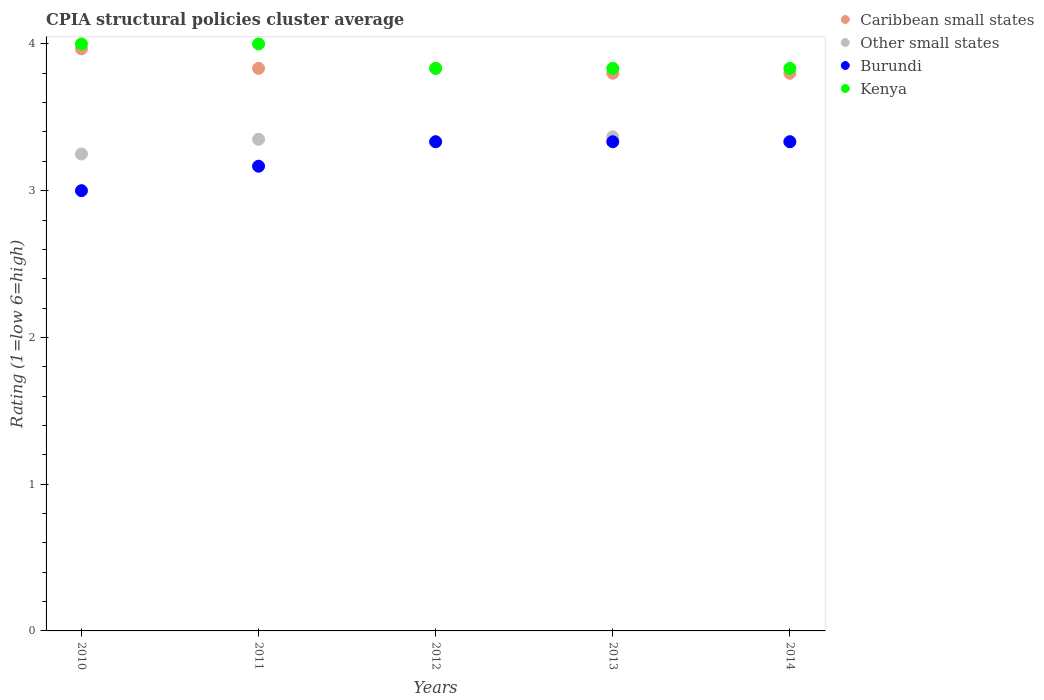Is the number of dotlines equal to the number of legend labels?
Offer a very short reply. Yes. Across all years, what is the minimum CPIA rating in Caribbean small states?
Ensure brevity in your answer.  3.8. In which year was the CPIA rating in Caribbean small states minimum?
Give a very brief answer. 2014. What is the total CPIA rating in Other small states in the graph?
Keep it short and to the point. 16.63. What is the difference between the CPIA rating in Burundi in 2011 and that in 2014?
Provide a succinct answer. -0.17. What is the difference between the CPIA rating in Burundi in 2011 and the CPIA rating in Other small states in 2012?
Keep it short and to the point. -0.17. What is the average CPIA rating in Caribbean small states per year?
Give a very brief answer. 3.85. In the year 2012, what is the difference between the CPIA rating in Other small states and CPIA rating in Kenya?
Provide a succinct answer. -0.5. What is the ratio of the CPIA rating in Burundi in 2010 to that in 2012?
Offer a very short reply. 0.9. What is the difference between the highest and the lowest CPIA rating in Caribbean small states?
Give a very brief answer. 0.17. How many dotlines are there?
Your response must be concise. 4. How many years are there in the graph?
Provide a succinct answer. 5. Are the values on the major ticks of Y-axis written in scientific E-notation?
Keep it short and to the point. No. Does the graph contain any zero values?
Offer a very short reply. No. Where does the legend appear in the graph?
Ensure brevity in your answer.  Top right. How many legend labels are there?
Make the answer very short. 4. What is the title of the graph?
Offer a very short reply. CPIA structural policies cluster average. Does "South Africa" appear as one of the legend labels in the graph?
Provide a short and direct response. No. What is the label or title of the Y-axis?
Provide a succinct answer. Rating (1=low 6=high). What is the Rating (1=low 6=high) of Caribbean small states in 2010?
Give a very brief answer. 3.97. What is the Rating (1=low 6=high) of Kenya in 2010?
Give a very brief answer. 4. What is the Rating (1=low 6=high) of Caribbean small states in 2011?
Your response must be concise. 3.83. What is the Rating (1=low 6=high) in Other small states in 2011?
Your answer should be compact. 3.35. What is the Rating (1=low 6=high) in Burundi in 2011?
Ensure brevity in your answer.  3.17. What is the Rating (1=low 6=high) of Caribbean small states in 2012?
Provide a succinct answer. 3.83. What is the Rating (1=low 6=high) in Other small states in 2012?
Your response must be concise. 3.33. What is the Rating (1=low 6=high) in Burundi in 2012?
Ensure brevity in your answer.  3.33. What is the Rating (1=low 6=high) in Kenya in 2012?
Your answer should be very brief. 3.83. What is the Rating (1=low 6=high) of Caribbean small states in 2013?
Make the answer very short. 3.8. What is the Rating (1=low 6=high) in Other small states in 2013?
Your response must be concise. 3.37. What is the Rating (1=low 6=high) of Burundi in 2013?
Give a very brief answer. 3.33. What is the Rating (1=low 6=high) in Kenya in 2013?
Provide a succinct answer. 3.83. What is the Rating (1=low 6=high) in Caribbean small states in 2014?
Your answer should be compact. 3.8. What is the Rating (1=low 6=high) in Other small states in 2014?
Your answer should be very brief. 3.33. What is the Rating (1=low 6=high) of Burundi in 2014?
Your response must be concise. 3.33. What is the Rating (1=low 6=high) of Kenya in 2014?
Make the answer very short. 3.83. Across all years, what is the maximum Rating (1=low 6=high) in Caribbean small states?
Offer a terse response. 3.97. Across all years, what is the maximum Rating (1=low 6=high) of Other small states?
Provide a short and direct response. 3.37. Across all years, what is the maximum Rating (1=low 6=high) of Burundi?
Provide a short and direct response. 3.33. Across all years, what is the minimum Rating (1=low 6=high) of Caribbean small states?
Your response must be concise. 3.8. Across all years, what is the minimum Rating (1=low 6=high) in Other small states?
Provide a succinct answer. 3.25. Across all years, what is the minimum Rating (1=low 6=high) of Burundi?
Your answer should be compact. 3. Across all years, what is the minimum Rating (1=low 6=high) in Kenya?
Provide a succinct answer. 3.83. What is the total Rating (1=low 6=high) of Caribbean small states in the graph?
Make the answer very short. 19.23. What is the total Rating (1=low 6=high) of Other small states in the graph?
Your response must be concise. 16.63. What is the total Rating (1=low 6=high) in Burundi in the graph?
Offer a very short reply. 16.17. What is the total Rating (1=low 6=high) of Kenya in the graph?
Your response must be concise. 19.5. What is the difference between the Rating (1=low 6=high) of Caribbean small states in 2010 and that in 2011?
Ensure brevity in your answer.  0.13. What is the difference between the Rating (1=low 6=high) of Kenya in 2010 and that in 2011?
Provide a succinct answer. 0. What is the difference between the Rating (1=low 6=high) in Caribbean small states in 2010 and that in 2012?
Offer a terse response. 0.13. What is the difference between the Rating (1=low 6=high) of Other small states in 2010 and that in 2012?
Your response must be concise. -0.08. What is the difference between the Rating (1=low 6=high) of Kenya in 2010 and that in 2012?
Offer a very short reply. 0.17. What is the difference between the Rating (1=low 6=high) in Caribbean small states in 2010 and that in 2013?
Your response must be concise. 0.17. What is the difference between the Rating (1=low 6=high) of Other small states in 2010 and that in 2013?
Your response must be concise. -0.12. What is the difference between the Rating (1=low 6=high) in Burundi in 2010 and that in 2013?
Offer a terse response. -0.33. What is the difference between the Rating (1=low 6=high) in Kenya in 2010 and that in 2013?
Provide a short and direct response. 0.17. What is the difference between the Rating (1=low 6=high) of Other small states in 2010 and that in 2014?
Your response must be concise. -0.08. What is the difference between the Rating (1=low 6=high) of Burundi in 2010 and that in 2014?
Provide a short and direct response. -0.33. What is the difference between the Rating (1=low 6=high) in Caribbean small states in 2011 and that in 2012?
Keep it short and to the point. 0. What is the difference between the Rating (1=low 6=high) in Other small states in 2011 and that in 2012?
Provide a succinct answer. 0.02. What is the difference between the Rating (1=low 6=high) in Kenya in 2011 and that in 2012?
Keep it short and to the point. 0.17. What is the difference between the Rating (1=low 6=high) of Caribbean small states in 2011 and that in 2013?
Provide a short and direct response. 0.03. What is the difference between the Rating (1=low 6=high) in Other small states in 2011 and that in 2013?
Provide a succinct answer. -0.02. What is the difference between the Rating (1=low 6=high) of Caribbean small states in 2011 and that in 2014?
Offer a terse response. 0.03. What is the difference between the Rating (1=low 6=high) in Other small states in 2011 and that in 2014?
Give a very brief answer. 0.02. What is the difference between the Rating (1=low 6=high) in Kenya in 2011 and that in 2014?
Keep it short and to the point. 0.17. What is the difference between the Rating (1=low 6=high) in Other small states in 2012 and that in 2013?
Offer a very short reply. -0.03. What is the difference between the Rating (1=low 6=high) in Kenya in 2012 and that in 2013?
Provide a succinct answer. 0. What is the difference between the Rating (1=low 6=high) of Other small states in 2012 and that in 2014?
Your answer should be compact. 0. What is the difference between the Rating (1=low 6=high) in Burundi in 2012 and that in 2014?
Your answer should be compact. 0. What is the difference between the Rating (1=low 6=high) of Kenya in 2012 and that in 2014?
Give a very brief answer. 0. What is the difference between the Rating (1=low 6=high) of Other small states in 2013 and that in 2014?
Offer a terse response. 0.03. What is the difference between the Rating (1=low 6=high) of Burundi in 2013 and that in 2014?
Your answer should be very brief. 0. What is the difference between the Rating (1=low 6=high) in Caribbean small states in 2010 and the Rating (1=low 6=high) in Other small states in 2011?
Provide a short and direct response. 0.62. What is the difference between the Rating (1=low 6=high) of Caribbean small states in 2010 and the Rating (1=low 6=high) of Kenya in 2011?
Keep it short and to the point. -0.03. What is the difference between the Rating (1=low 6=high) of Other small states in 2010 and the Rating (1=low 6=high) of Burundi in 2011?
Your answer should be compact. 0.08. What is the difference between the Rating (1=low 6=high) of Other small states in 2010 and the Rating (1=low 6=high) of Kenya in 2011?
Provide a short and direct response. -0.75. What is the difference between the Rating (1=low 6=high) of Caribbean small states in 2010 and the Rating (1=low 6=high) of Other small states in 2012?
Give a very brief answer. 0.63. What is the difference between the Rating (1=low 6=high) of Caribbean small states in 2010 and the Rating (1=low 6=high) of Burundi in 2012?
Offer a terse response. 0.63. What is the difference between the Rating (1=low 6=high) in Caribbean small states in 2010 and the Rating (1=low 6=high) in Kenya in 2012?
Provide a short and direct response. 0.13. What is the difference between the Rating (1=low 6=high) in Other small states in 2010 and the Rating (1=low 6=high) in Burundi in 2012?
Your answer should be compact. -0.08. What is the difference between the Rating (1=low 6=high) in Other small states in 2010 and the Rating (1=low 6=high) in Kenya in 2012?
Offer a very short reply. -0.58. What is the difference between the Rating (1=low 6=high) of Caribbean small states in 2010 and the Rating (1=low 6=high) of Other small states in 2013?
Your answer should be very brief. 0.6. What is the difference between the Rating (1=low 6=high) of Caribbean small states in 2010 and the Rating (1=low 6=high) of Burundi in 2013?
Your answer should be very brief. 0.63. What is the difference between the Rating (1=low 6=high) of Caribbean small states in 2010 and the Rating (1=low 6=high) of Kenya in 2013?
Your response must be concise. 0.13. What is the difference between the Rating (1=low 6=high) of Other small states in 2010 and the Rating (1=low 6=high) of Burundi in 2013?
Make the answer very short. -0.08. What is the difference between the Rating (1=low 6=high) of Other small states in 2010 and the Rating (1=low 6=high) of Kenya in 2013?
Ensure brevity in your answer.  -0.58. What is the difference between the Rating (1=low 6=high) in Burundi in 2010 and the Rating (1=low 6=high) in Kenya in 2013?
Offer a very short reply. -0.83. What is the difference between the Rating (1=low 6=high) in Caribbean small states in 2010 and the Rating (1=low 6=high) in Other small states in 2014?
Provide a succinct answer. 0.63. What is the difference between the Rating (1=low 6=high) in Caribbean small states in 2010 and the Rating (1=low 6=high) in Burundi in 2014?
Give a very brief answer. 0.63. What is the difference between the Rating (1=low 6=high) of Caribbean small states in 2010 and the Rating (1=low 6=high) of Kenya in 2014?
Give a very brief answer. 0.13. What is the difference between the Rating (1=low 6=high) in Other small states in 2010 and the Rating (1=low 6=high) in Burundi in 2014?
Your response must be concise. -0.08. What is the difference between the Rating (1=low 6=high) in Other small states in 2010 and the Rating (1=low 6=high) in Kenya in 2014?
Ensure brevity in your answer.  -0.58. What is the difference between the Rating (1=low 6=high) in Burundi in 2010 and the Rating (1=low 6=high) in Kenya in 2014?
Offer a terse response. -0.83. What is the difference between the Rating (1=low 6=high) in Caribbean small states in 2011 and the Rating (1=low 6=high) in Other small states in 2012?
Your answer should be compact. 0.5. What is the difference between the Rating (1=low 6=high) of Caribbean small states in 2011 and the Rating (1=low 6=high) of Kenya in 2012?
Your answer should be very brief. 0. What is the difference between the Rating (1=low 6=high) in Other small states in 2011 and the Rating (1=low 6=high) in Burundi in 2012?
Offer a very short reply. 0.02. What is the difference between the Rating (1=low 6=high) of Other small states in 2011 and the Rating (1=low 6=high) of Kenya in 2012?
Ensure brevity in your answer.  -0.48. What is the difference between the Rating (1=low 6=high) of Caribbean small states in 2011 and the Rating (1=low 6=high) of Other small states in 2013?
Offer a terse response. 0.47. What is the difference between the Rating (1=low 6=high) of Other small states in 2011 and the Rating (1=low 6=high) of Burundi in 2013?
Provide a succinct answer. 0.02. What is the difference between the Rating (1=low 6=high) in Other small states in 2011 and the Rating (1=low 6=high) in Kenya in 2013?
Provide a succinct answer. -0.48. What is the difference between the Rating (1=low 6=high) of Other small states in 2011 and the Rating (1=low 6=high) of Burundi in 2014?
Offer a very short reply. 0.02. What is the difference between the Rating (1=low 6=high) in Other small states in 2011 and the Rating (1=low 6=high) in Kenya in 2014?
Give a very brief answer. -0.48. What is the difference between the Rating (1=low 6=high) of Caribbean small states in 2012 and the Rating (1=low 6=high) of Other small states in 2013?
Offer a very short reply. 0.47. What is the difference between the Rating (1=low 6=high) in Other small states in 2012 and the Rating (1=low 6=high) in Kenya in 2013?
Ensure brevity in your answer.  -0.5. What is the difference between the Rating (1=low 6=high) of Caribbean small states in 2012 and the Rating (1=low 6=high) of Other small states in 2014?
Give a very brief answer. 0.5. What is the difference between the Rating (1=low 6=high) in Caribbean small states in 2012 and the Rating (1=low 6=high) in Burundi in 2014?
Provide a short and direct response. 0.5. What is the difference between the Rating (1=low 6=high) in Caribbean small states in 2012 and the Rating (1=low 6=high) in Kenya in 2014?
Provide a succinct answer. 0. What is the difference between the Rating (1=low 6=high) of Other small states in 2012 and the Rating (1=low 6=high) of Burundi in 2014?
Keep it short and to the point. 0. What is the difference between the Rating (1=low 6=high) of Other small states in 2012 and the Rating (1=low 6=high) of Kenya in 2014?
Make the answer very short. -0.5. What is the difference between the Rating (1=low 6=high) in Burundi in 2012 and the Rating (1=low 6=high) in Kenya in 2014?
Your answer should be very brief. -0.5. What is the difference between the Rating (1=low 6=high) in Caribbean small states in 2013 and the Rating (1=low 6=high) in Other small states in 2014?
Offer a terse response. 0.47. What is the difference between the Rating (1=low 6=high) in Caribbean small states in 2013 and the Rating (1=low 6=high) in Burundi in 2014?
Provide a succinct answer. 0.47. What is the difference between the Rating (1=low 6=high) in Caribbean small states in 2013 and the Rating (1=low 6=high) in Kenya in 2014?
Ensure brevity in your answer.  -0.03. What is the difference between the Rating (1=low 6=high) in Other small states in 2013 and the Rating (1=low 6=high) in Burundi in 2014?
Your answer should be compact. 0.03. What is the difference between the Rating (1=low 6=high) of Other small states in 2013 and the Rating (1=low 6=high) of Kenya in 2014?
Offer a very short reply. -0.47. What is the average Rating (1=low 6=high) of Caribbean small states per year?
Your answer should be very brief. 3.85. What is the average Rating (1=low 6=high) in Other small states per year?
Your answer should be compact. 3.33. What is the average Rating (1=low 6=high) in Burundi per year?
Offer a very short reply. 3.23. What is the average Rating (1=low 6=high) in Kenya per year?
Provide a short and direct response. 3.9. In the year 2010, what is the difference between the Rating (1=low 6=high) in Caribbean small states and Rating (1=low 6=high) in Other small states?
Provide a succinct answer. 0.72. In the year 2010, what is the difference between the Rating (1=low 6=high) of Caribbean small states and Rating (1=low 6=high) of Burundi?
Your answer should be very brief. 0.97. In the year 2010, what is the difference between the Rating (1=low 6=high) in Caribbean small states and Rating (1=low 6=high) in Kenya?
Keep it short and to the point. -0.03. In the year 2010, what is the difference between the Rating (1=low 6=high) of Other small states and Rating (1=low 6=high) of Burundi?
Keep it short and to the point. 0.25. In the year 2010, what is the difference between the Rating (1=low 6=high) in Other small states and Rating (1=low 6=high) in Kenya?
Your answer should be compact. -0.75. In the year 2011, what is the difference between the Rating (1=low 6=high) of Caribbean small states and Rating (1=low 6=high) of Other small states?
Your answer should be very brief. 0.48. In the year 2011, what is the difference between the Rating (1=low 6=high) of Caribbean small states and Rating (1=low 6=high) of Burundi?
Provide a succinct answer. 0.67. In the year 2011, what is the difference between the Rating (1=low 6=high) in Other small states and Rating (1=low 6=high) in Burundi?
Make the answer very short. 0.18. In the year 2011, what is the difference between the Rating (1=low 6=high) in Other small states and Rating (1=low 6=high) in Kenya?
Make the answer very short. -0.65. In the year 2012, what is the difference between the Rating (1=low 6=high) in Caribbean small states and Rating (1=low 6=high) in Burundi?
Your answer should be very brief. 0.5. In the year 2012, what is the difference between the Rating (1=low 6=high) in Other small states and Rating (1=low 6=high) in Kenya?
Give a very brief answer. -0.5. In the year 2013, what is the difference between the Rating (1=low 6=high) of Caribbean small states and Rating (1=low 6=high) of Other small states?
Keep it short and to the point. 0.43. In the year 2013, what is the difference between the Rating (1=low 6=high) of Caribbean small states and Rating (1=low 6=high) of Burundi?
Make the answer very short. 0.47. In the year 2013, what is the difference between the Rating (1=low 6=high) in Caribbean small states and Rating (1=low 6=high) in Kenya?
Provide a short and direct response. -0.03. In the year 2013, what is the difference between the Rating (1=low 6=high) in Other small states and Rating (1=low 6=high) in Burundi?
Provide a short and direct response. 0.03. In the year 2013, what is the difference between the Rating (1=low 6=high) of Other small states and Rating (1=low 6=high) of Kenya?
Provide a short and direct response. -0.47. In the year 2013, what is the difference between the Rating (1=low 6=high) of Burundi and Rating (1=low 6=high) of Kenya?
Your answer should be compact. -0.5. In the year 2014, what is the difference between the Rating (1=low 6=high) in Caribbean small states and Rating (1=low 6=high) in Other small states?
Keep it short and to the point. 0.47. In the year 2014, what is the difference between the Rating (1=low 6=high) in Caribbean small states and Rating (1=low 6=high) in Burundi?
Keep it short and to the point. 0.47. In the year 2014, what is the difference between the Rating (1=low 6=high) in Caribbean small states and Rating (1=low 6=high) in Kenya?
Keep it short and to the point. -0.03. In the year 2014, what is the difference between the Rating (1=low 6=high) of Other small states and Rating (1=low 6=high) of Burundi?
Offer a terse response. 0. What is the ratio of the Rating (1=low 6=high) in Caribbean small states in 2010 to that in 2011?
Provide a succinct answer. 1.03. What is the ratio of the Rating (1=low 6=high) in Other small states in 2010 to that in 2011?
Give a very brief answer. 0.97. What is the ratio of the Rating (1=low 6=high) of Burundi in 2010 to that in 2011?
Provide a short and direct response. 0.95. What is the ratio of the Rating (1=low 6=high) in Kenya in 2010 to that in 2011?
Your response must be concise. 1. What is the ratio of the Rating (1=low 6=high) in Caribbean small states in 2010 to that in 2012?
Ensure brevity in your answer.  1.03. What is the ratio of the Rating (1=low 6=high) of Burundi in 2010 to that in 2012?
Offer a very short reply. 0.9. What is the ratio of the Rating (1=low 6=high) in Kenya in 2010 to that in 2012?
Your response must be concise. 1.04. What is the ratio of the Rating (1=low 6=high) in Caribbean small states in 2010 to that in 2013?
Provide a short and direct response. 1.04. What is the ratio of the Rating (1=low 6=high) in Other small states in 2010 to that in 2013?
Give a very brief answer. 0.97. What is the ratio of the Rating (1=low 6=high) of Burundi in 2010 to that in 2013?
Offer a terse response. 0.9. What is the ratio of the Rating (1=low 6=high) of Kenya in 2010 to that in 2013?
Make the answer very short. 1.04. What is the ratio of the Rating (1=low 6=high) in Caribbean small states in 2010 to that in 2014?
Ensure brevity in your answer.  1.04. What is the ratio of the Rating (1=low 6=high) of Kenya in 2010 to that in 2014?
Keep it short and to the point. 1.04. What is the ratio of the Rating (1=low 6=high) of Caribbean small states in 2011 to that in 2012?
Offer a very short reply. 1. What is the ratio of the Rating (1=low 6=high) of Burundi in 2011 to that in 2012?
Offer a terse response. 0.95. What is the ratio of the Rating (1=low 6=high) of Kenya in 2011 to that in 2012?
Ensure brevity in your answer.  1.04. What is the ratio of the Rating (1=low 6=high) in Caribbean small states in 2011 to that in 2013?
Keep it short and to the point. 1.01. What is the ratio of the Rating (1=low 6=high) in Kenya in 2011 to that in 2013?
Your answer should be compact. 1.04. What is the ratio of the Rating (1=low 6=high) of Caribbean small states in 2011 to that in 2014?
Keep it short and to the point. 1.01. What is the ratio of the Rating (1=low 6=high) in Other small states in 2011 to that in 2014?
Your answer should be compact. 1. What is the ratio of the Rating (1=low 6=high) of Kenya in 2011 to that in 2014?
Your answer should be compact. 1.04. What is the ratio of the Rating (1=low 6=high) in Caribbean small states in 2012 to that in 2013?
Keep it short and to the point. 1.01. What is the ratio of the Rating (1=low 6=high) of Other small states in 2012 to that in 2013?
Offer a very short reply. 0.99. What is the ratio of the Rating (1=low 6=high) of Burundi in 2012 to that in 2013?
Offer a very short reply. 1. What is the ratio of the Rating (1=low 6=high) in Kenya in 2012 to that in 2013?
Offer a very short reply. 1. What is the ratio of the Rating (1=low 6=high) of Caribbean small states in 2012 to that in 2014?
Offer a terse response. 1.01. What is the ratio of the Rating (1=low 6=high) of Other small states in 2013 to that in 2014?
Offer a very short reply. 1.01. What is the difference between the highest and the second highest Rating (1=low 6=high) in Caribbean small states?
Your answer should be compact. 0.13. What is the difference between the highest and the second highest Rating (1=low 6=high) in Other small states?
Your answer should be very brief. 0.02. What is the difference between the highest and the second highest Rating (1=low 6=high) of Burundi?
Your answer should be very brief. 0. What is the difference between the highest and the lowest Rating (1=low 6=high) of Caribbean small states?
Provide a succinct answer. 0.17. What is the difference between the highest and the lowest Rating (1=low 6=high) of Other small states?
Make the answer very short. 0.12. What is the difference between the highest and the lowest Rating (1=low 6=high) of Burundi?
Provide a short and direct response. 0.33. 